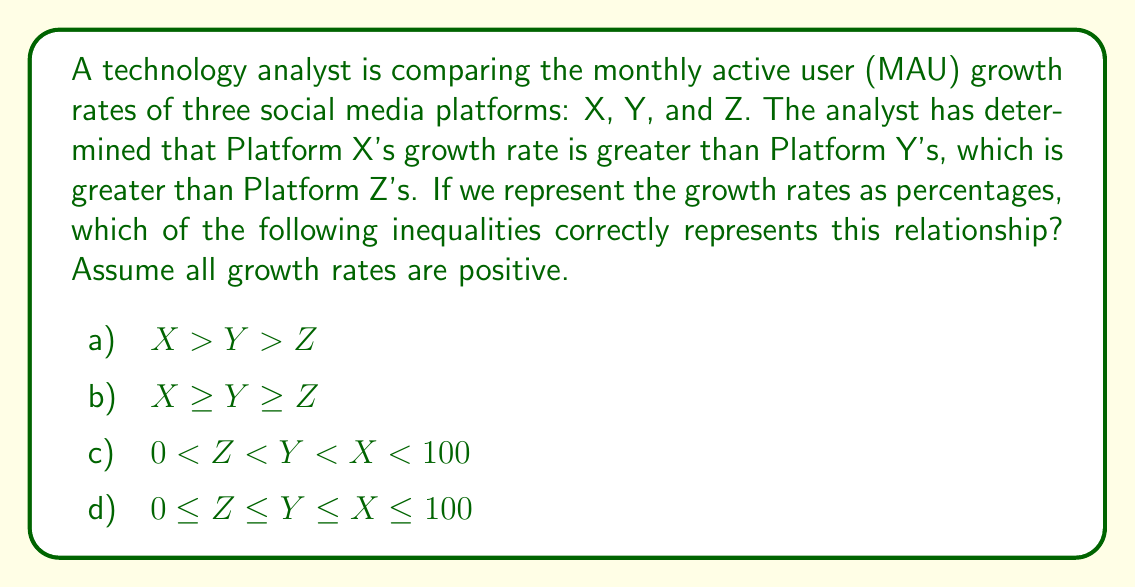Show me your answer to this math problem. Let's analyze this step-by-step:

1) We are told that Platform X's growth rate is greater than Platform Y's, which is greater than Platform Z's. This can be represented mathematically as:

   $X > Y > Z$

2) We are also told to assume all growth rates are positive, which means:

   $X > 0$, $Y > 0$, and $Z > 0$

3) Growth rates are typically expressed as percentages, which means they should be between 0% and 100%. In decimal form, this would be:

   $0 < X < 1$, $0 < Y < 1$, and $0 < Z < 1$

4) Combining all this information, we can say:

   $0 < Z < Y < X < 1$

5) To convert this to percentages, we multiply everything by 100:

   $0 < Z < Y < X < 100$

6) Now, let's evaluate each option:

   a) $X > Y > Z$ : This is correct, but doesn't include the constraints of being positive and less than 100%.
   b) $X \geq Y \geq Z$ : This allows for equality, which contradicts the "greater than" relationship given.
   c) $0 < Z < Y < X < 100$ : This correctly represents all the given information.
   d) $0 \leq Z \leq Y \leq X \leq 100$ : This allows for equality, which contradicts the "greater than" relationship given.

Therefore, option c) is the most accurate representation of the given information.
Answer: c) $0 < Z < Y < X < 100$ 